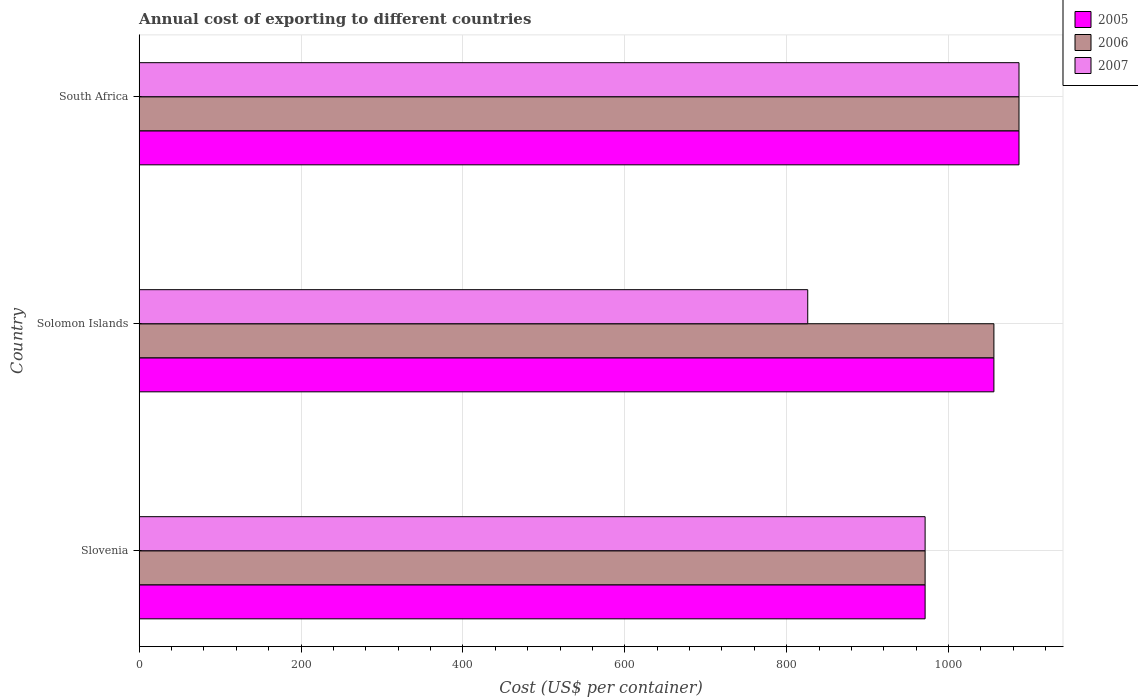How many different coloured bars are there?
Your response must be concise. 3. How many groups of bars are there?
Keep it short and to the point. 3. Are the number of bars per tick equal to the number of legend labels?
Keep it short and to the point. Yes. What is the label of the 1st group of bars from the top?
Your answer should be compact. South Africa. What is the total annual cost of exporting in 2005 in South Africa?
Your answer should be compact. 1087. Across all countries, what is the maximum total annual cost of exporting in 2005?
Provide a succinct answer. 1087. Across all countries, what is the minimum total annual cost of exporting in 2007?
Ensure brevity in your answer.  826. In which country was the total annual cost of exporting in 2007 maximum?
Offer a very short reply. South Africa. In which country was the total annual cost of exporting in 2005 minimum?
Keep it short and to the point. Slovenia. What is the total total annual cost of exporting in 2007 in the graph?
Offer a very short reply. 2884. What is the difference between the total annual cost of exporting in 2005 in Slovenia and that in Solomon Islands?
Keep it short and to the point. -85. What is the difference between the total annual cost of exporting in 2007 in Solomon Islands and the total annual cost of exporting in 2005 in Slovenia?
Offer a terse response. -145. What is the average total annual cost of exporting in 2007 per country?
Provide a short and direct response. 961.33. What is the difference between the total annual cost of exporting in 2005 and total annual cost of exporting in 2007 in Solomon Islands?
Make the answer very short. 230. What is the ratio of the total annual cost of exporting in 2007 in Slovenia to that in South Africa?
Your answer should be very brief. 0.89. Is the difference between the total annual cost of exporting in 2005 in Slovenia and South Africa greater than the difference between the total annual cost of exporting in 2007 in Slovenia and South Africa?
Provide a succinct answer. No. What is the difference between the highest and the second highest total annual cost of exporting in 2007?
Your answer should be very brief. 116. What is the difference between the highest and the lowest total annual cost of exporting in 2006?
Offer a very short reply. 116. Is it the case that in every country, the sum of the total annual cost of exporting in 2007 and total annual cost of exporting in 2005 is greater than the total annual cost of exporting in 2006?
Your response must be concise. Yes. How many bars are there?
Make the answer very short. 9. Are all the bars in the graph horizontal?
Provide a succinct answer. Yes. How many countries are there in the graph?
Your answer should be very brief. 3. What is the difference between two consecutive major ticks on the X-axis?
Offer a very short reply. 200. Does the graph contain any zero values?
Offer a very short reply. No. Does the graph contain grids?
Offer a very short reply. Yes. How many legend labels are there?
Your answer should be compact. 3. How are the legend labels stacked?
Your response must be concise. Vertical. What is the title of the graph?
Offer a very short reply. Annual cost of exporting to different countries. What is the label or title of the X-axis?
Your response must be concise. Cost (US$ per container). What is the label or title of the Y-axis?
Ensure brevity in your answer.  Country. What is the Cost (US$ per container) of 2005 in Slovenia?
Offer a very short reply. 971. What is the Cost (US$ per container) of 2006 in Slovenia?
Give a very brief answer. 971. What is the Cost (US$ per container) in 2007 in Slovenia?
Give a very brief answer. 971. What is the Cost (US$ per container) in 2005 in Solomon Islands?
Ensure brevity in your answer.  1056. What is the Cost (US$ per container) in 2006 in Solomon Islands?
Offer a very short reply. 1056. What is the Cost (US$ per container) in 2007 in Solomon Islands?
Provide a succinct answer. 826. What is the Cost (US$ per container) of 2005 in South Africa?
Keep it short and to the point. 1087. What is the Cost (US$ per container) of 2006 in South Africa?
Provide a short and direct response. 1087. What is the Cost (US$ per container) of 2007 in South Africa?
Your answer should be very brief. 1087. Across all countries, what is the maximum Cost (US$ per container) in 2005?
Provide a succinct answer. 1087. Across all countries, what is the maximum Cost (US$ per container) in 2006?
Give a very brief answer. 1087. Across all countries, what is the maximum Cost (US$ per container) in 2007?
Your answer should be compact. 1087. Across all countries, what is the minimum Cost (US$ per container) of 2005?
Your answer should be compact. 971. Across all countries, what is the minimum Cost (US$ per container) of 2006?
Make the answer very short. 971. Across all countries, what is the minimum Cost (US$ per container) of 2007?
Your answer should be compact. 826. What is the total Cost (US$ per container) of 2005 in the graph?
Offer a very short reply. 3114. What is the total Cost (US$ per container) in 2006 in the graph?
Your response must be concise. 3114. What is the total Cost (US$ per container) of 2007 in the graph?
Your response must be concise. 2884. What is the difference between the Cost (US$ per container) in 2005 in Slovenia and that in Solomon Islands?
Offer a very short reply. -85. What is the difference between the Cost (US$ per container) of 2006 in Slovenia and that in Solomon Islands?
Make the answer very short. -85. What is the difference between the Cost (US$ per container) in 2007 in Slovenia and that in Solomon Islands?
Provide a short and direct response. 145. What is the difference between the Cost (US$ per container) in 2005 in Slovenia and that in South Africa?
Offer a very short reply. -116. What is the difference between the Cost (US$ per container) in 2006 in Slovenia and that in South Africa?
Your answer should be very brief. -116. What is the difference between the Cost (US$ per container) in 2007 in Slovenia and that in South Africa?
Keep it short and to the point. -116. What is the difference between the Cost (US$ per container) of 2005 in Solomon Islands and that in South Africa?
Ensure brevity in your answer.  -31. What is the difference between the Cost (US$ per container) in 2006 in Solomon Islands and that in South Africa?
Your response must be concise. -31. What is the difference between the Cost (US$ per container) in 2007 in Solomon Islands and that in South Africa?
Your answer should be very brief. -261. What is the difference between the Cost (US$ per container) of 2005 in Slovenia and the Cost (US$ per container) of 2006 in Solomon Islands?
Your response must be concise. -85. What is the difference between the Cost (US$ per container) of 2005 in Slovenia and the Cost (US$ per container) of 2007 in Solomon Islands?
Offer a terse response. 145. What is the difference between the Cost (US$ per container) of 2006 in Slovenia and the Cost (US$ per container) of 2007 in Solomon Islands?
Your answer should be compact. 145. What is the difference between the Cost (US$ per container) in 2005 in Slovenia and the Cost (US$ per container) in 2006 in South Africa?
Provide a short and direct response. -116. What is the difference between the Cost (US$ per container) in 2005 in Slovenia and the Cost (US$ per container) in 2007 in South Africa?
Give a very brief answer. -116. What is the difference between the Cost (US$ per container) in 2006 in Slovenia and the Cost (US$ per container) in 2007 in South Africa?
Provide a succinct answer. -116. What is the difference between the Cost (US$ per container) in 2005 in Solomon Islands and the Cost (US$ per container) in 2006 in South Africa?
Make the answer very short. -31. What is the difference between the Cost (US$ per container) of 2005 in Solomon Islands and the Cost (US$ per container) of 2007 in South Africa?
Offer a terse response. -31. What is the difference between the Cost (US$ per container) of 2006 in Solomon Islands and the Cost (US$ per container) of 2007 in South Africa?
Provide a short and direct response. -31. What is the average Cost (US$ per container) of 2005 per country?
Provide a succinct answer. 1038. What is the average Cost (US$ per container) in 2006 per country?
Make the answer very short. 1038. What is the average Cost (US$ per container) of 2007 per country?
Your answer should be compact. 961.33. What is the difference between the Cost (US$ per container) in 2005 and Cost (US$ per container) in 2006 in Slovenia?
Provide a short and direct response. 0. What is the difference between the Cost (US$ per container) in 2005 and Cost (US$ per container) in 2007 in Slovenia?
Offer a terse response. 0. What is the difference between the Cost (US$ per container) in 2005 and Cost (US$ per container) in 2007 in Solomon Islands?
Provide a succinct answer. 230. What is the difference between the Cost (US$ per container) in 2006 and Cost (US$ per container) in 2007 in Solomon Islands?
Offer a terse response. 230. What is the difference between the Cost (US$ per container) of 2005 and Cost (US$ per container) of 2006 in South Africa?
Provide a short and direct response. 0. What is the ratio of the Cost (US$ per container) of 2005 in Slovenia to that in Solomon Islands?
Make the answer very short. 0.92. What is the ratio of the Cost (US$ per container) in 2006 in Slovenia to that in Solomon Islands?
Your response must be concise. 0.92. What is the ratio of the Cost (US$ per container) of 2007 in Slovenia to that in Solomon Islands?
Ensure brevity in your answer.  1.18. What is the ratio of the Cost (US$ per container) of 2005 in Slovenia to that in South Africa?
Provide a succinct answer. 0.89. What is the ratio of the Cost (US$ per container) in 2006 in Slovenia to that in South Africa?
Offer a terse response. 0.89. What is the ratio of the Cost (US$ per container) of 2007 in Slovenia to that in South Africa?
Your answer should be compact. 0.89. What is the ratio of the Cost (US$ per container) of 2005 in Solomon Islands to that in South Africa?
Offer a very short reply. 0.97. What is the ratio of the Cost (US$ per container) in 2006 in Solomon Islands to that in South Africa?
Your response must be concise. 0.97. What is the ratio of the Cost (US$ per container) of 2007 in Solomon Islands to that in South Africa?
Make the answer very short. 0.76. What is the difference between the highest and the second highest Cost (US$ per container) in 2005?
Give a very brief answer. 31. What is the difference between the highest and the second highest Cost (US$ per container) of 2007?
Keep it short and to the point. 116. What is the difference between the highest and the lowest Cost (US$ per container) in 2005?
Your answer should be very brief. 116. What is the difference between the highest and the lowest Cost (US$ per container) in 2006?
Your answer should be compact. 116. What is the difference between the highest and the lowest Cost (US$ per container) in 2007?
Ensure brevity in your answer.  261. 